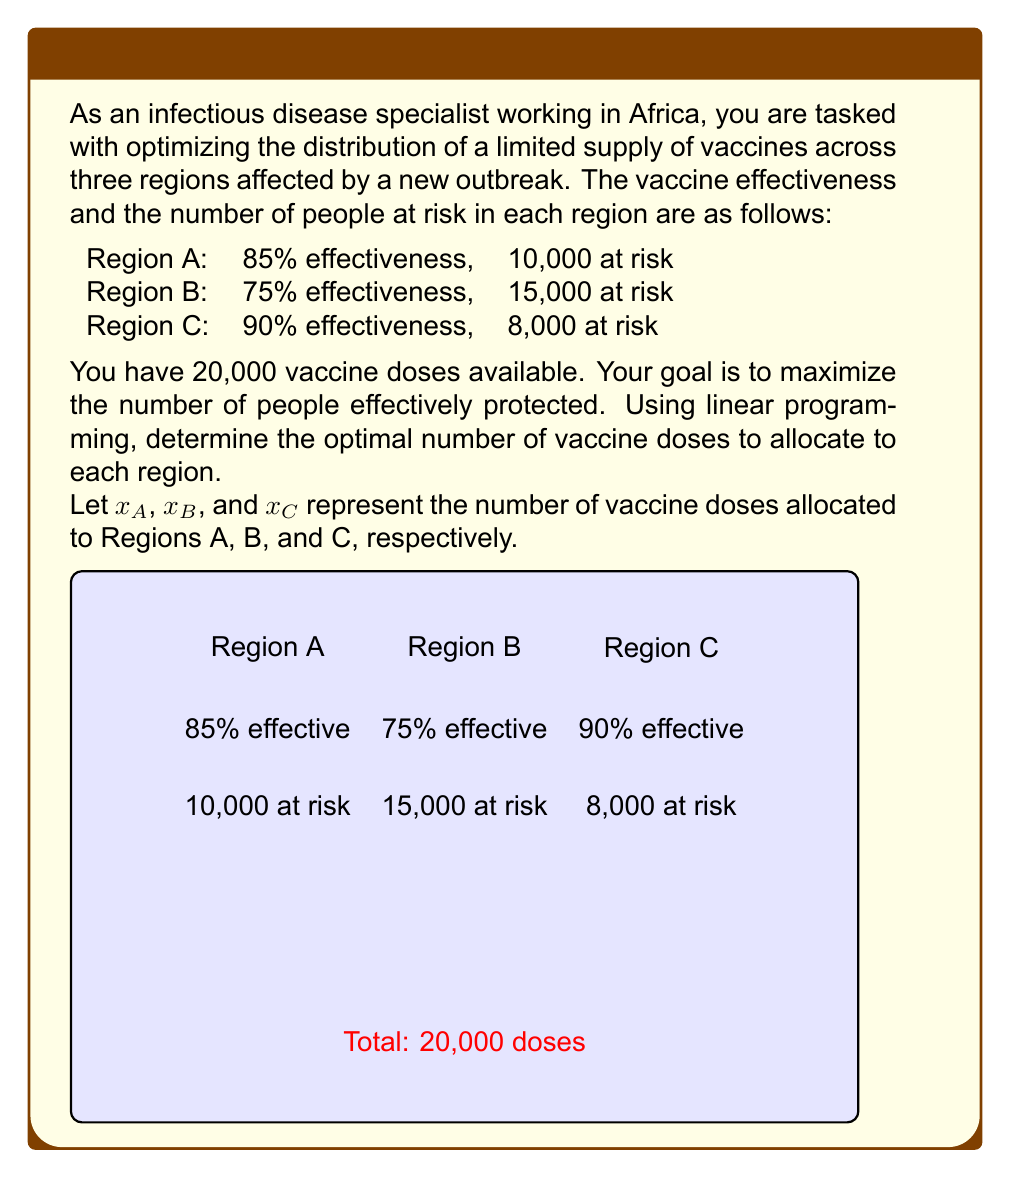Solve this math problem. To solve this linear programming problem, we'll follow these steps:

1) Define the objective function:
   Maximize $Z = 0.85x_A + 0.75x_B + 0.90x_C$

2) Set up the constraints:
   $x_A + x_B + x_C \leq 20,000$ (total available doses)
   $x_A \leq 10,000$ (max for Region A)
   $x_B \leq 15,000$ (max for Region B)
   $x_C \leq 8,000$ (max for Region C)
   $x_A, x_B, x_C \geq 0$ (non-negativity)

3) Solve using the simplex method or a linear programming solver. However, we can also reason through this problem:

   - Region C has the highest effectiveness, so we should allocate the maximum possible to C first: 8,000 doses.
   - Region A has the next highest effectiveness, so we allocate the maximum to A: 10,000 doses.
   - We've used 18,000 doses, leaving 2,000 for Region B.

4) Check the solution:
   $x_A = 10,000$
   $x_B = 2,000$
   $x_C = 8,000$

   Total doses: $10,000 + 2,000 + 8,000 = 20,000$

5) Calculate the number of people effectively protected:
   Region A: $0.85 \times 10,000 = 8,500$
   Region B: $0.75 \times 2,000 = 1,500$
   Region C: $0.90 \times 8,000 = 7,200$

   Total: $8,500 + 1,500 + 7,200 = 17,200$

This allocation maximizes the number of people effectively protected given the constraints.
Answer: Region A: 10,000 doses, Region B: 2,000 doses, Region C: 8,000 doses 